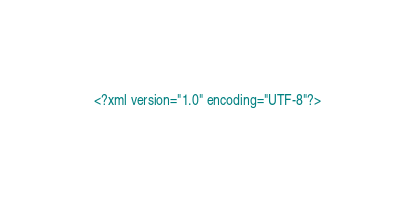Convert code to text. <code><loc_0><loc_0><loc_500><loc_500><_XML_><?xml version="1.0" encoding="UTF-8"?></code> 